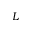<formula> <loc_0><loc_0><loc_500><loc_500>L</formula> 